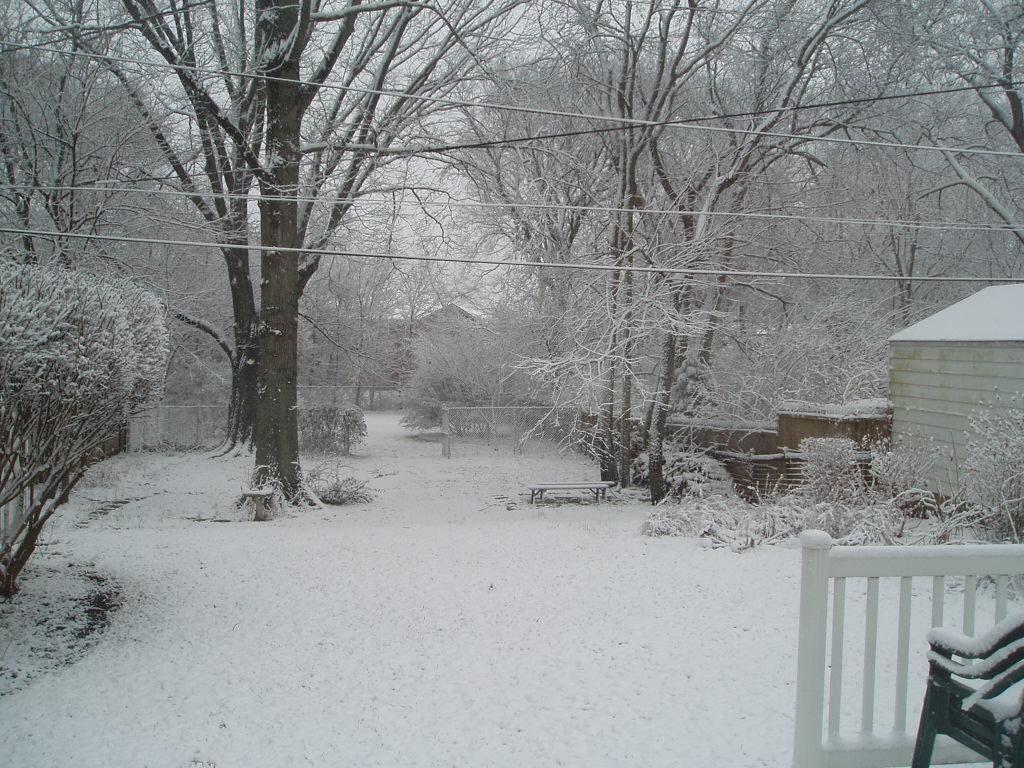In one or two sentences, can you explain what this image depicts? In this picture we can see the trees, snow, houses, railing, chairs and other objects. 